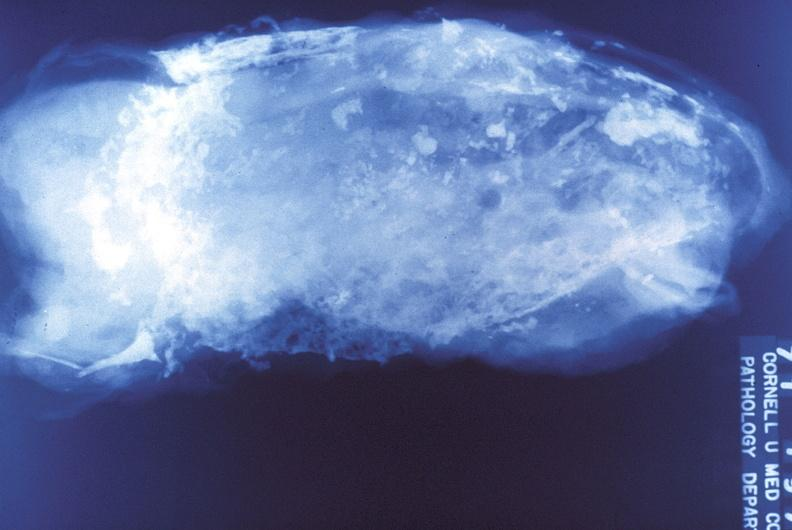what does this image show?
Answer the question using a single word or phrase. Tuberculosis 